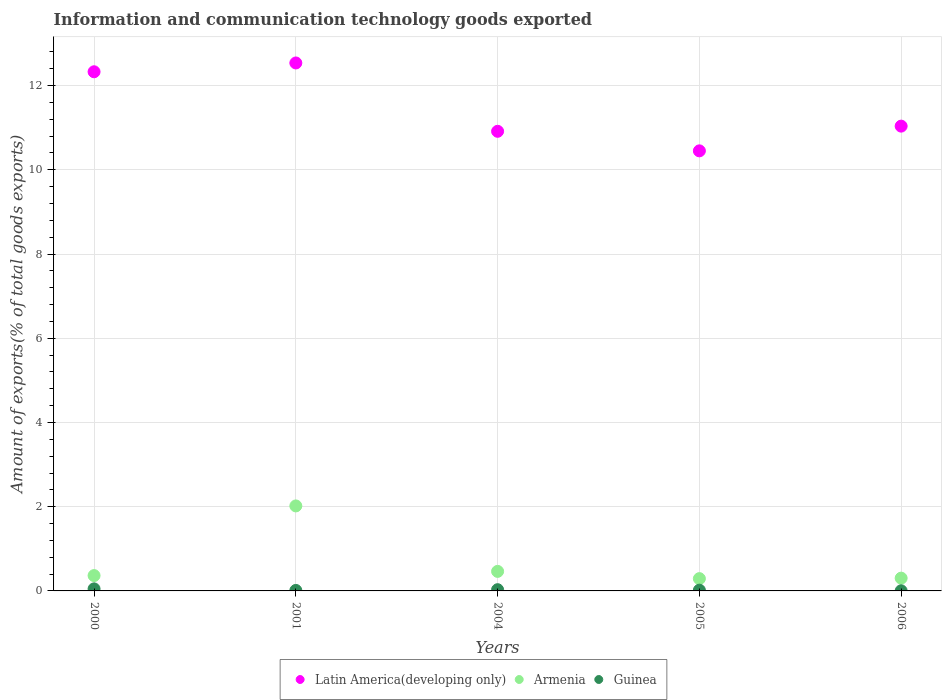Is the number of dotlines equal to the number of legend labels?
Provide a short and direct response. Yes. What is the amount of goods exported in Latin America(developing only) in 2004?
Your response must be concise. 10.91. Across all years, what is the maximum amount of goods exported in Latin America(developing only)?
Your response must be concise. 12.54. Across all years, what is the minimum amount of goods exported in Guinea?
Give a very brief answer. 0. In which year was the amount of goods exported in Armenia maximum?
Offer a terse response. 2001. In which year was the amount of goods exported in Latin America(developing only) minimum?
Your answer should be compact. 2005. What is the total amount of goods exported in Armenia in the graph?
Your response must be concise. 3.44. What is the difference between the amount of goods exported in Latin America(developing only) in 2000 and that in 2001?
Offer a terse response. -0.21. What is the difference between the amount of goods exported in Latin America(developing only) in 2004 and the amount of goods exported in Guinea in 2005?
Your answer should be very brief. 10.9. What is the average amount of goods exported in Latin America(developing only) per year?
Offer a terse response. 11.45. In the year 2004, what is the difference between the amount of goods exported in Armenia and amount of goods exported in Guinea?
Give a very brief answer. 0.43. In how many years, is the amount of goods exported in Latin America(developing only) greater than 7.2 %?
Provide a succinct answer. 5. What is the ratio of the amount of goods exported in Guinea in 2005 to that in 2006?
Your response must be concise. 5.41. Is the amount of goods exported in Latin America(developing only) in 2001 less than that in 2005?
Your answer should be compact. No. What is the difference between the highest and the second highest amount of goods exported in Latin America(developing only)?
Provide a short and direct response. 0.21. What is the difference between the highest and the lowest amount of goods exported in Guinea?
Offer a terse response. 0.05. Is the sum of the amount of goods exported in Guinea in 2000 and 2001 greater than the maximum amount of goods exported in Latin America(developing only) across all years?
Provide a short and direct response. No. Does the amount of goods exported in Latin America(developing only) monotonically increase over the years?
Provide a short and direct response. No. Is the amount of goods exported in Armenia strictly less than the amount of goods exported in Latin America(developing only) over the years?
Offer a very short reply. Yes. How many dotlines are there?
Your answer should be very brief. 3. How many years are there in the graph?
Keep it short and to the point. 5. What is the difference between two consecutive major ticks on the Y-axis?
Make the answer very short. 2. Are the values on the major ticks of Y-axis written in scientific E-notation?
Your answer should be very brief. No. Does the graph contain any zero values?
Keep it short and to the point. No. How are the legend labels stacked?
Offer a terse response. Horizontal. What is the title of the graph?
Provide a short and direct response. Information and communication technology goods exported. Does "Macedonia" appear as one of the legend labels in the graph?
Ensure brevity in your answer.  No. What is the label or title of the Y-axis?
Keep it short and to the point. Amount of exports(% of total goods exports). What is the Amount of exports(% of total goods exports) in Latin America(developing only) in 2000?
Keep it short and to the point. 12.33. What is the Amount of exports(% of total goods exports) of Armenia in 2000?
Your answer should be very brief. 0.36. What is the Amount of exports(% of total goods exports) of Guinea in 2000?
Provide a succinct answer. 0.05. What is the Amount of exports(% of total goods exports) of Latin America(developing only) in 2001?
Provide a short and direct response. 12.54. What is the Amount of exports(% of total goods exports) in Armenia in 2001?
Offer a terse response. 2.02. What is the Amount of exports(% of total goods exports) in Guinea in 2001?
Provide a succinct answer. 0.01. What is the Amount of exports(% of total goods exports) in Latin America(developing only) in 2004?
Your answer should be very brief. 10.91. What is the Amount of exports(% of total goods exports) in Armenia in 2004?
Provide a short and direct response. 0.46. What is the Amount of exports(% of total goods exports) of Guinea in 2004?
Your answer should be very brief. 0.03. What is the Amount of exports(% of total goods exports) of Latin America(developing only) in 2005?
Make the answer very short. 10.45. What is the Amount of exports(% of total goods exports) of Armenia in 2005?
Your answer should be compact. 0.29. What is the Amount of exports(% of total goods exports) in Guinea in 2005?
Your answer should be very brief. 0.02. What is the Amount of exports(% of total goods exports) of Latin America(developing only) in 2006?
Offer a terse response. 11.04. What is the Amount of exports(% of total goods exports) of Armenia in 2006?
Keep it short and to the point. 0.3. What is the Amount of exports(% of total goods exports) in Guinea in 2006?
Provide a short and direct response. 0. Across all years, what is the maximum Amount of exports(% of total goods exports) in Latin America(developing only)?
Keep it short and to the point. 12.54. Across all years, what is the maximum Amount of exports(% of total goods exports) in Armenia?
Your answer should be very brief. 2.02. Across all years, what is the maximum Amount of exports(% of total goods exports) in Guinea?
Give a very brief answer. 0.05. Across all years, what is the minimum Amount of exports(% of total goods exports) of Latin America(developing only)?
Make the answer very short. 10.45. Across all years, what is the minimum Amount of exports(% of total goods exports) of Armenia?
Provide a short and direct response. 0.29. Across all years, what is the minimum Amount of exports(% of total goods exports) in Guinea?
Provide a succinct answer. 0. What is the total Amount of exports(% of total goods exports) in Latin America(developing only) in the graph?
Ensure brevity in your answer.  57.27. What is the total Amount of exports(% of total goods exports) of Armenia in the graph?
Offer a very short reply. 3.44. What is the total Amount of exports(% of total goods exports) in Guinea in the graph?
Your answer should be compact. 0.11. What is the difference between the Amount of exports(% of total goods exports) of Latin America(developing only) in 2000 and that in 2001?
Offer a very short reply. -0.21. What is the difference between the Amount of exports(% of total goods exports) in Armenia in 2000 and that in 2001?
Ensure brevity in your answer.  -1.65. What is the difference between the Amount of exports(% of total goods exports) in Guinea in 2000 and that in 2001?
Your answer should be very brief. 0.04. What is the difference between the Amount of exports(% of total goods exports) in Latin America(developing only) in 2000 and that in 2004?
Offer a terse response. 1.41. What is the difference between the Amount of exports(% of total goods exports) of Armenia in 2000 and that in 2004?
Keep it short and to the point. -0.1. What is the difference between the Amount of exports(% of total goods exports) of Guinea in 2000 and that in 2004?
Ensure brevity in your answer.  0.02. What is the difference between the Amount of exports(% of total goods exports) of Latin America(developing only) in 2000 and that in 2005?
Offer a terse response. 1.88. What is the difference between the Amount of exports(% of total goods exports) in Armenia in 2000 and that in 2005?
Offer a very short reply. 0.07. What is the difference between the Amount of exports(% of total goods exports) in Guinea in 2000 and that in 2005?
Your response must be concise. 0.03. What is the difference between the Amount of exports(% of total goods exports) of Latin America(developing only) in 2000 and that in 2006?
Your response must be concise. 1.29. What is the difference between the Amount of exports(% of total goods exports) of Armenia in 2000 and that in 2006?
Provide a succinct answer. 0.06. What is the difference between the Amount of exports(% of total goods exports) in Guinea in 2000 and that in 2006?
Give a very brief answer. 0.05. What is the difference between the Amount of exports(% of total goods exports) of Latin America(developing only) in 2001 and that in 2004?
Your response must be concise. 1.62. What is the difference between the Amount of exports(% of total goods exports) of Armenia in 2001 and that in 2004?
Ensure brevity in your answer.  1.55. What is the difference between the Amount of exports(% of total goods exports) in Guinea in 2001 and that in 2004?
Provide a succinct answer. -0.02. What is the difference between the Amount of exports(% of total goods exports) of Latin America(developing only) in 2001 and that in 2005?
Your answer should be very brief. 2.09. What is the difference between the Amount of exports(% of total goods exports) of Armenia in 2001 and that in 2005?
Provide a succinct answer. 1.73. What is the difference between the Amount of exports(% of total goods exports) of Guinea in 2001 and that in 2005?
Make the answer very short. -0.01. What is the difference between the Amount of exports(% of total goods exports) of Armenia in 2001 and that in 2006?
Keep it short and to the point. 1.72. What is the difference between the Amount of exports(% of total goods exports) of Guinea in 2001 and that in 2006?
Your response must be concise. 0.01. What is the difference between the Amount of exports(% of total goods exports) of Latin America(developing only) in 2004 and that in 2005?
Keep it short and to the point. 0.46. What is the difference between the Amount of exports(% of total goods exports) in Armenia in 2004 and that in 2005?
Ensure brevity in your answer.  0.17. What is the difference between the Amount of exports(% of total goods exports) in Guinea in 2004 and that in 2005?
Provide a succinct answer. 0.01. What is the difference between the Amount of exports(% of total goods exports) in Latin America(developing only) in 2004 and that in 2006?
Keep it short and to the point. -0.12. What is the difference between the Amount of exports(% of total goods exports) of Armenia in 2004 and that in 2006?
Make the answer very short. 0.16. What is the difference between the Amount of exports(% of total goods exports) in Guinea in 2004 and that in 2006?
Keep it short and to the point. 0.03. What is the difference between the Amount of exports(% of total goods exports) of Latin America(developing only) in 2005 and that in 2006?
Your answer should be compact. -0.59. What is the difference between the Amount of exports(% of total goods exports) of Armenia in 2005 and that in 2006?
Offer a very short reply. -0.01. What is the difference between the Amount of exports(% of total goods exports) in Guinea in 2005 and that in 2006?
Your answer should be compact. 0.01. What is the difference between the Amount of exports(% of total goods exports) in Latin America(developing only) in 2000 and the Amount of exports(% of total goods exports) in Armenia in 2001?
Your answer should be compact. 10.31. What is the difference between the Amount of exports(% of total goods exports) of Latin America(developing only) in 2000 and the Amount of exports(% of total goods exports) of Guinea in 2001?
Keep it short and to the point. 12.32. What is the difference between the Amount of exports(% of total goods exports) of Armenia in 2000 and the Amount of exports(% of total goods exports) of Guinea in 2001?
Offer a terse response. 0.35. What is the difference between the Amount of exports(% of total goods exports) in Latin America(developing only) in 2000 and the Amount of exports(% of total goods exports) in Armenia in 2004?
Your answer should be very brief. 11.86. What is the difference between the Amount of exports(% of total goods exports) of Latin America(developing only) in 2000 and the Amount of exports(% of total goods exports) of Guinea in 2004?
Offer a terse response. 12.3. What is the difference between the Amount of exports(% of total goods exports) in Armenia in 2000 and the Amount of exports(% of total goods exports) in Guinea in 2004?
Your answer should be very brief. 0.34. What is the difference between the Amount of exports(% of total goods exports) of Latin America(developing only) in 2000 and the Amount of exports(% of total goods exports) of Armenia in 2005?
Your response must be concise. 12.04. What is the difference between the Amount of exports(% of total goods exports) of Latin America(developing only) in 2000 and the Amount of exports(% of total goods exports) of Guinea in 2005?
Provide a succinct answer. 12.31. What is the difference between the Amount of exports(% of total goods exports) of Armenia in 2000 and the Amount of exports(% of total goods exports) of Guinea in 2005?
Your answer should be compact. 0.35. What is the difference between the Amount of exports(% of total goods exports) in Latin America(developing only) in 2000 and the Amount of exports(% of total goods exports) in Armenia in 2006?
Ensure brevity in your answer.  12.03. What is the difference between the Amount of exports(% of total goods exports) of Latin America(developing only) in 2000 and the Amount of exports(% of total goods exports) of Guinea in 2006?
Your answer should be very brief. 12.33. What is the difference between the Amount of exports(% of total goods exports) in Armenia in 2000 and the Amount of exports(% of total goods exports) in Guinea in 2006?
Offer a very short reply. 0.36. What is the difference between the Amount of exports(% of total goods exports) in Latin America(developing only) in 2001 and the Amount of exports(% of total goods exports) in Armenia in 2004?
Make the answer very short. 12.07. What is the difference between the Amount of exports(% of total goods exports) in Latin America(developing only) in 2001 and the Amount of exports(% of total goods exports) in Guinea in 2004?
Your response must be concise. 12.51. What is the difference between the Amount of exports(% of total goods exports) in Armenia in 2001 and the Amount of exports(% of total goods exports) in Guinea in 2004?
Your response must be concise. 1.99. What is the difference between the Amount of exports(% of total goods exports) in Latin America(developing only) in 2001 and the Amount of exports(% of total goods exports) in Armenia in 2005?
Ensure brevity in your answer.  12.25. What is the difference between the Amount of exports(% of total goods exports) in Latin America(developing only) in 2001 and the Amount of exports(% of total goods exports) in Guinea in 2005?
Ensure brevity in your answer.  12.52. What is the difference between the Amount of exports(% of total goods exports) of Armenia in 2001 and the Amount of exports(% of total goods exports) of Guinea in 2005?
Ensure brevity in your answer.  2. What is the difference between the Amount of exports(% of total goods exports) of Latin America(developing only) in 2001 and the Amount of exports(% of total goods exports) of Armenia in 2006?
Offer a very short reply. 12.23. What is the difference between the Amount of exports(% of total goods exports) in Latin America(developing only) in 2001 and the Amount of exports(% of total goods exports) in Guinea in 2006?
Your response must be concise. 12.53. What is the difference between the Amount of exports(% of total goods exports) in Armenia in 2001 and the Amount of exports(% of total goods exports) in Guinea in 2006?
Your answer should be very brief. 2.02. What is the difference between the Amount of exports(% of total goods exports) in Latin America(developing only) in 2004 and the Amount of exports(% of total goods exports) in Armenia in 2005?
Provide a short and direct response. 10.62. What is the difference between the Amount of exports(% of total goods exports) of Latin America(developing only) in 2004 and the Amount of exports(% of total goods exports) of Guinea in 2005?
Keep it short and to the point. 10.9. What is the difference between the Amount of exports(% of total goods exports) of Armenia in 2004 and the Amount of exports(% of total goods exports) of Guinea in 2005?
Your answer should be very brief. 0.45. What is the difference between the Amount of exports(% of total goods exports) of Latin America(developing only) in 2004 and the Amount of exports(% of total goods exports) of Armenia in 2006?
Give a very brief answer. 10.61. What is the difference between the Amount of exports(% of total goods exports) in Latin America(developing only) in 2004 and the Amount of exports(% of total goods exports) in Guinea in 2006?
Keep it short and to the point. 10.91. What is the difference between the Amount of exports(% of total goods exports) of Armenia in 2004 and the Amount of exports(% of total goods exports) of Guinea in 2006?
Ensure brevity in your answer.  0.46. What is the difference between the Amount of exports(% of total goods exports) of Latin America(developing only) in 2005 and the Amount of exports(% of total goods exports) of Armenia in 2006?
Your answer should be compact. 10.15. What is the difference between the Amount of exports(% of total goods exports) of Latin America(developing only) in 2005 and the Amount of exports(% of total goods exports) of Guinea in 2006?
Ensure brevity in your answer.  10.45. What is the difference between the Amount of exports(% of total goods exports) in Armenia in 2005 and the Amount of exports(% of total goods exports) in Guinea in 2006?
Offer a terse response. 0.29. What is the average Amount of exports(% of total goods exports) in Latin America(developing only) per year?
Make the answer very short. 11.45. What is the average Amount of exports(% of total goods exports) in Armenia per year?
Provide a short and direct response. 0.69. What is the average Amount of exports(% of total goods exports) of Guinea per year?
Ensure brevity in your answer.  0.02. In the year 2000, what is the difference between the Amount of exports(% of total goods exports) of Latin America(developing only) and Amount of exports(% of total goods exports) of Armenia?
Offer a terse response. 11.96. In the year 2000, what is the difference between the Amount of exports(% of total goods exports) in Latin America(developing only) and Amount of exports(% of total goods exports) in Guinea?
Provide a succinct answer. 12.28. In the year 2000, what is the difference between the Amount of exports(% of total goods exports) in Armenia and Amount of exports(% of total goods exports) in Guinea?
Provide a succinct answer. 0.32. In the year 2001, what is the difference between the Amount of exports(% of total goods exports) of Latin America(developing only) and Amount of exports(% of total goods exports) of Armenia?
Your answer should be compact. 10.52. In the year 2001, what is the difference between the Amount of exports(% of total goods exports) of Latin America(developing only) and Amount of exports(% of total goods exports) of Guinea?
Provide a short and direct response. 12.53. In the year 2001, what is the difference between the Amount of exports(% of total goods exports) of Armenia and Amount of exports(% of total goods exports) of Guinea?
Your answer should be compact. 2.01. In the year 2004, what is the difference between the Amount of exports(% of total goods exports) of Latin America(developing only) and Amount of exports(% of total goods exports) of Armenia?
Give a very brief answer. 10.45. In the year 2004, what is the difference between the Amount of exports(% of total goods exports) in Latin America(developing only) and Amount of exports(% of total goods exports) in Guinea?
Give a very brief answer. 10.89. In the year 2004, what is the difference between the Amount of exports(% of total goods exports) of Armenia and Amount of exports(% of total goods exports) of Guinea?
Your answer should be very brief. 0.43. In the year 2005, what is the difference between the Amount of exports(% of total goods exports) of Latin America(developing only) and Amount of exports(% of total goods exports) of Armenia?
Ensure brevity in your answer.  10.16. In the year 2005, what is the difference between the Amount of exports(% of total goods exports) of Latin America(developing only) and Amount of exports(% of total goods exports) of Guinea?
Make the answer very short. 10.43. In the year 2005, what is the difference between the Amount of exports(% of total goods exports) of Armenia and Amount of exports(% of total goods exports) of Guinea?
Make the answer very short. 0.27. In the year 2006, what is the difference between the Amount of exports(% of total goods exports) in Latin America(developing only) and Amount of exports(% of total goods exports) in Armenia?
Ensure brevity in your answer.  10.73. In the year 2006, what is the difference between the Amount of exports(% of total goods exports) of Latin America(developing only) and Amount of exports(% of total goods exports) of Guinea?
Keep it short and to the point. 11.03. What is the ratio of the Amount of exports(% of total goods exports) of Latin America(developing only) in 2000 to that in 2001?
Make the answer very short. 0.98. What is the ratio of the Amount of exports(% of total goods exports) in Armenia in 2000 to that in 2001?
Offer a terse response. 0.18. What is the ratio of the Amount of exports(% of total goods exports) of Guinea in 2000 to that in 2001?
Your answer should be compact. 4.12. What is the ratio of the Amount of exports(% of total goods exports) of Latin America(developing only) in 2000 to that in 2004?
Ensure brevity in your answer.  1.13. What is the ratio of the Amount of exports(% of total goods exports) in Armenia in 2000 to that in 2004?
Provide a short and direct response. 0.79. What is the ratio of the Amount of exports(% of total goods exports) in Guinea in 2000 to that in 2004?
Offer a very short reply. 1.66. What is the ratio of the Amount of exports(% of total goods exports) in Latin America(developing only) in 2000 to that in 2005?
Offer a terse response. 1.18. What is the ratio of the Amount of exports(% of total goods exports) of Armenia in 2000 to that in 2005?
Provide a short and direct response. 1.25. What is the ratio of the Amount of exports(% of total goods exports) of Guinea in 2000 to that in 2005?
Your response must be concise. 2.72. What is the ratio of the Amount of exports(% of total goods exports) of Latin America(developing only) in 2000 to that in 2006?
Give a very brief answer. 1.12. What is the ratio of the Amount of exports(% of total goods exports) in Armenia in 2000 to that in 2006?
Your answer should be very brief. 1.2. What is the ratio of the Amount of exports(% of total goods exports) in Guinea in 2000 to that in 2006?
Your answer should be compact. 14.72. What is the ratio of the Amount of exports(% of total goods exports) in Latin America(developing only) in 2001 to that in 2004?
Ensure brevity in your answer.  1.15. What is the ratio of the Amount of exports(% of total goods exports) in Armenia in 2001 to that in 2004?
Provide a short and direct response. 4.35. What is the ratio of the Amount of exports(% of total goods exports) of Guinea in 2001 to that in 2004?
Give a very brief answer. 0.4. What is the ratio of the Amount of exports(% of total goods exports) in Latin America(developing only) in 2001 to that in 2005?
Your answer should be very brief. 1.2. What is the ratio of the Amount of exports(% of total goods exports) in Armenia in 2001 to that in 2005?
Offer a terse response. 6.92. What is the ratio of the Amount of exports(% of total goods exports) of Guinea in 2001 to that in 2005?
Provide a succinct answer. 0.66. What is the ratio of the Amount of exports(% of total goods exports) of Latin America(developing only) in 2001 to that in 2006?
Provide a succinct answer. 1.14. What is the ratio of the Amount of exports(% of total goods exports) in Armenia in 2001 to that in 2006?
Keep it short and to the point. 6.66. What is the ratio of the Amount of exports(% of total goods exports) of Guinea in 2001 to that in 2006?
Provide a succinct answer. 3.58. What is the ratio of the Amount of exports(% of total goods exports) in Latin America(developing only) in 2004 to that in 2005?
Offer a terse response. 1.04. What is the ratio of the Amount of exports(% of total goods exports) of Armenia in 2004 to that in 2005?
Make the answer very short. 1.59. What is the ratio of the Amount of exports(% of total goods exports) of Guinea in 2004 to that in 2005?
Offer a terse response. 1.64. What is the ratio of the Amount of exports(% of total goods exports) of Latin America(developing only) in 2004 to that in 2006?
Provide a short and direct response. 0.99. What is the ratio of the Amount of exports(% of total goods exports) in Armenia in 2004 to that in 2006?
Your answer should be compact. 1.53. What is the ratio of the Amount of exports(% of total goods exports) in Guinea in 2004 to that in 2006?
Provide a short and direct response. 8.85. What is the ratio of the Amount of exports(% of total goods exports) in Latin America(developing only) in 2005 to that in 2006?
Your answer should be compact. 0.95. What is the ratio of the Amount of exports(% of total goods exports) of Armenia in 2005 to that in 2006?
Ensure brevity in your answer.  0.96. What is the ratio of the Amount of exports(% of total goods exports) in Guinea in 2005 to that in 2006?
Provide a short and direct response. 5.41. What is the difference between the highest and the second highest Amount of exports(% of total goods exports) in Latin America(developing only)?
Offer a terse response. 0.21. What is the difference between the highest and the second highest Amount of exports(% of total goods exports) of Armenia?
Make the answer very short. 1.55. What is the difference between the highest and the second highest Amount of exports(% of total goods exports) of Guinea?
Make the answer very short. 0.02. What is the difference between the highest and the lowest Amount of exports(% of total goods exports) in Latin America(developing only)?
Your answer should be very brief. 2.09. What is the difference between the highest and the lowest Amount of exports(% of total goods exports) in Armenia?
Give a very brief answer. 1.73. What is the difference between the highest and the lowest Amount of exports(% of total goods exports) of Guinea?
Your answer should be compact. 0.05. 